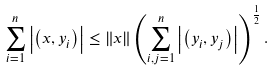<formula> <loc_0><loc_0><loc_500><loc_500>\sum _ { i = 1 } ^ { n } \left | \left ( x , y _ { i } \right ) \right | \leq \left \| x \right \| \left ( \sum _ { i , j = 1 } ^ { n } \left | \left ( y _ { i } , y _ { j } \right ) \right | \right ) ^ { \frac { 1 } { 2 } } .</formula> 